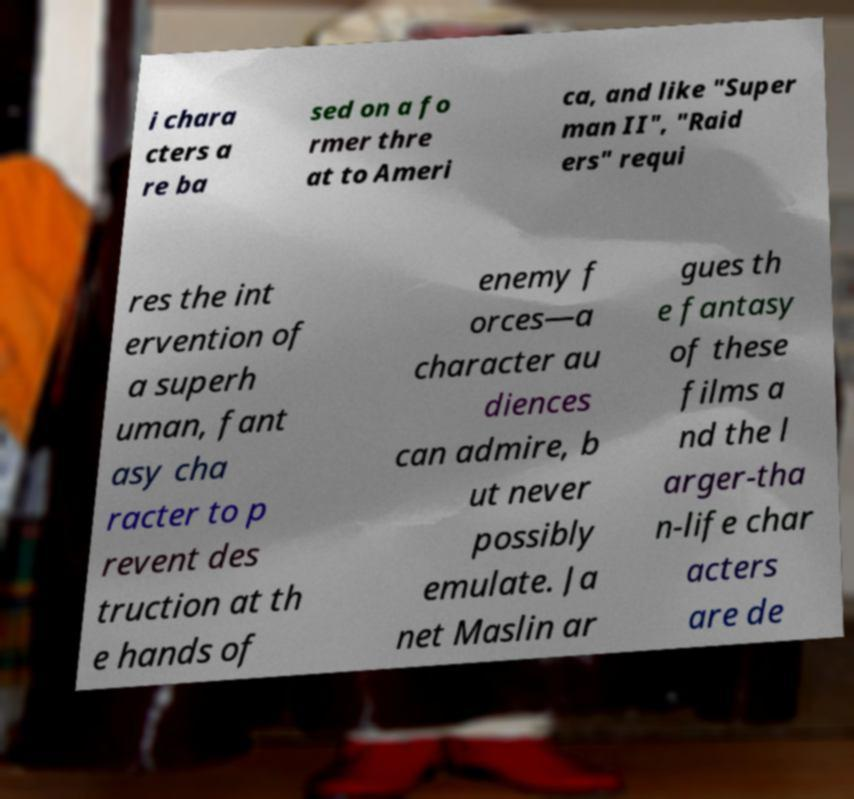Can you read and provide the text displayed in the image?This photo seems to have some interesting text. Can you extract and type it out for me? i chara cters a re ba sed on a fo rmer thre at to Ameri ca, and like "Super man II", "Raid ers" requi res the int ervention of a superh uman, fant asy cha racter to p revent des truction at th e hands of enemy f orces—a character au diences can admire, b ut never possibly emulate. Ja net Maslin ar gues th e fantasy of these films a nd the l arger-tha n-life char acters are de 